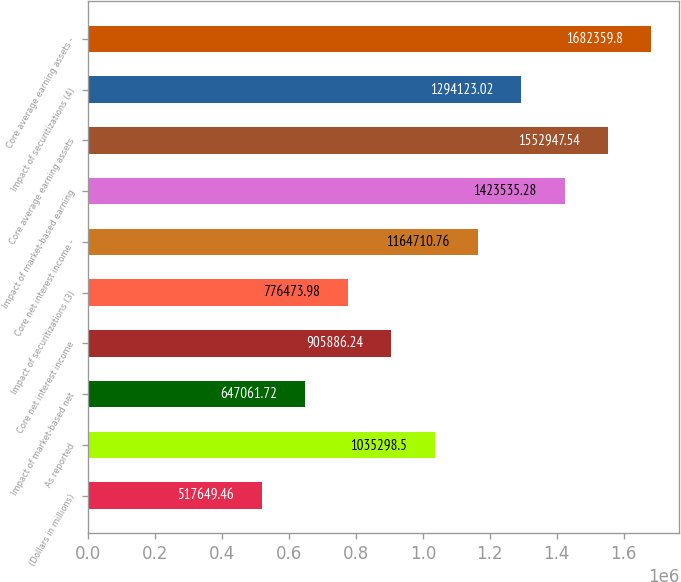<chart> <loc_0><loc_0><loc_500><loc_500><bar_chart><fcel>(Dollars in millions)<fcel>As reported<fcel>Impact of market-based net<fcel>Core net interest income<fcel>Impact of securitizations (3)<fcel>Core net interest income -<fcel>Impact of market-based earning<fcel>Core average earning assets<fcel>Impact of securitizations (4)<fcel>Core average earning assets -<nl><fcel>517649<fcel>1.0353e+06<fcel>647062<fcel>905886<fcel>776474<fcel>1.16471e+06<fcel>1.42354e+06<fcel>1.55295e+06<fcel>1.29412e+06<fcel>1.68236e+06<nl></chart> 